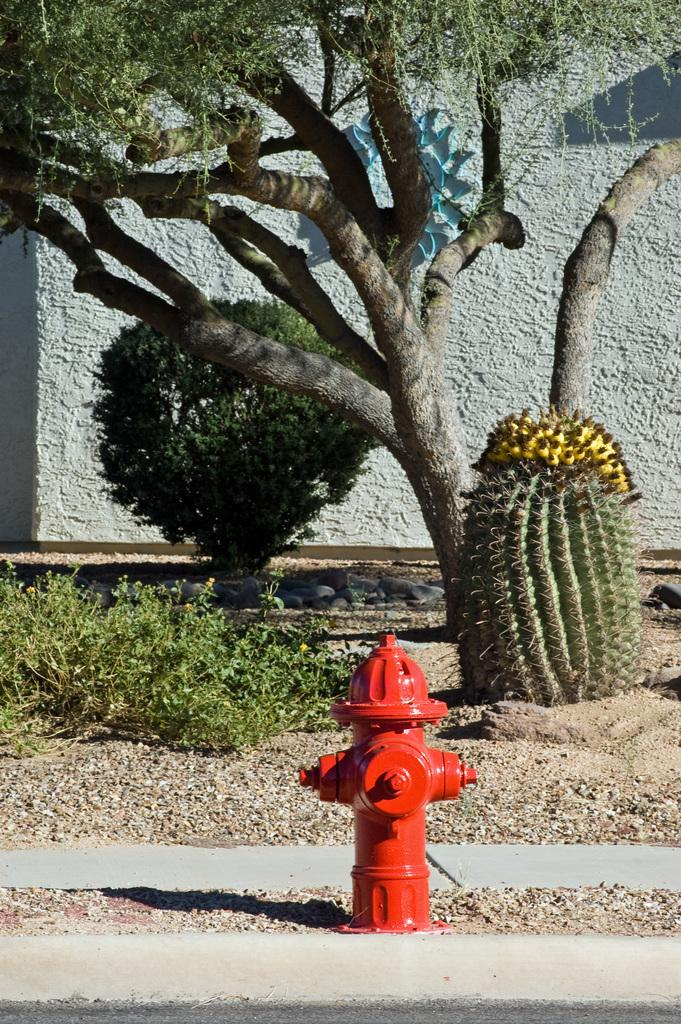What is the main object in the foreground of the image? There is a fire hydrant in the foreground of the image. What type of vegetation is present in the foreground of the image? Grass and a tree are visible in the foreground of the image. What other objects can be seen in the foreground of the image? House plants are visible in the foreground of the image. What is visible in the background of the image? There is a wall in the background of the image. Can you tell if the image was taken during the day or night? The image was likely taken during the day, as there is no indication of darkness or artificial lighting. What type of force is being exerted on the kitten in the image? There is no kitten present in the image, so no force is being exerted on it. How is the fire hydrant being used in the image? The fire hydrant is not being used in the image; it is simply a stationary object in the foreground. 